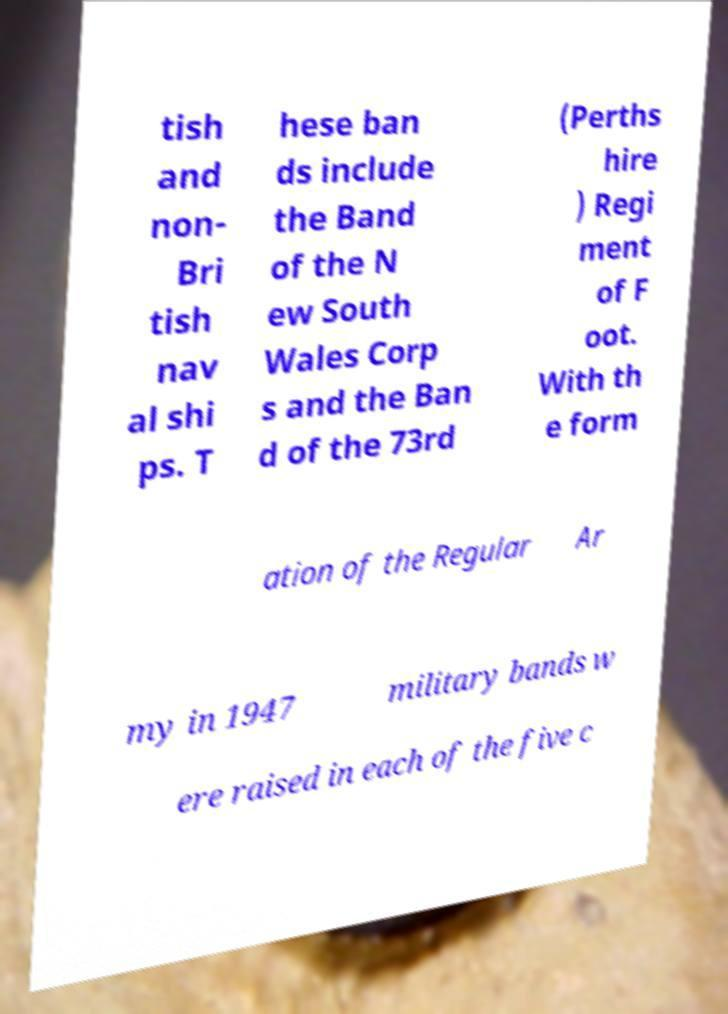Can you read and provide the text displayed in the image?This photo seems to have some interesting text. Can you extract and type it out for me? tish and non- Bri tish nav al shi ps. T hese ban ds include the Band of the N ew South Wales Corp s and the Ban d of the 73rd (Perths hire ) Regi ment of F oot. With th e form ation of the Regular Ar my in 1947 military bands w ere raised in each of the five c 